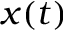Convert formula to latex. <formula><loc_0><loc_0><loc_500><loc_500>x ( t )</formula> 